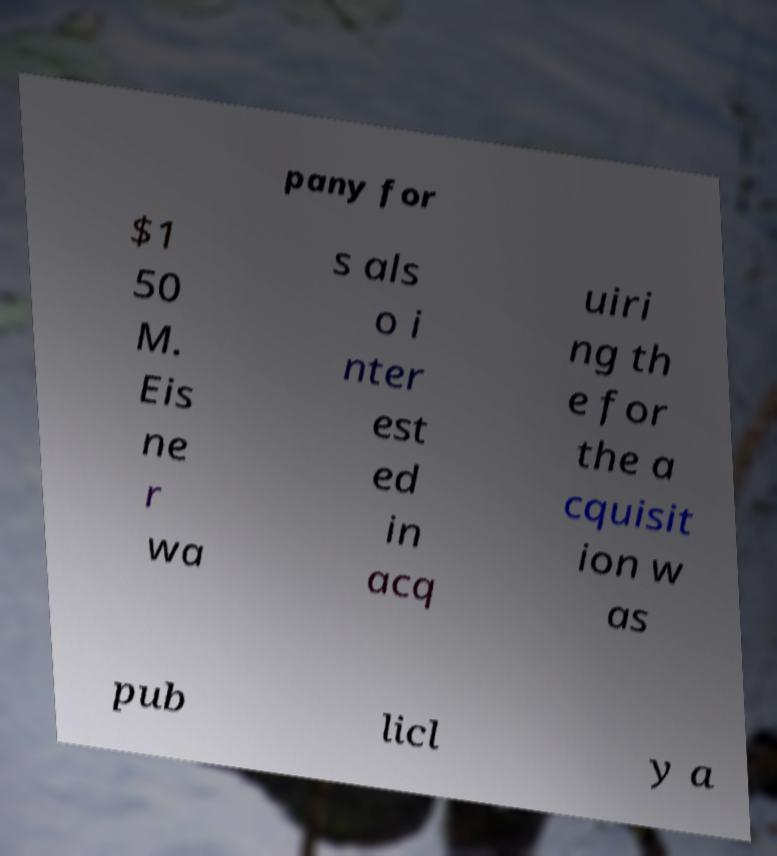Could you assist in decoding the text presented in this image and type it out clearly? pany for $1 50 M. Eis ne r wa s als o i nter est ed in acq uiri ng th e for the a cquisit ion w as pub licl y a 